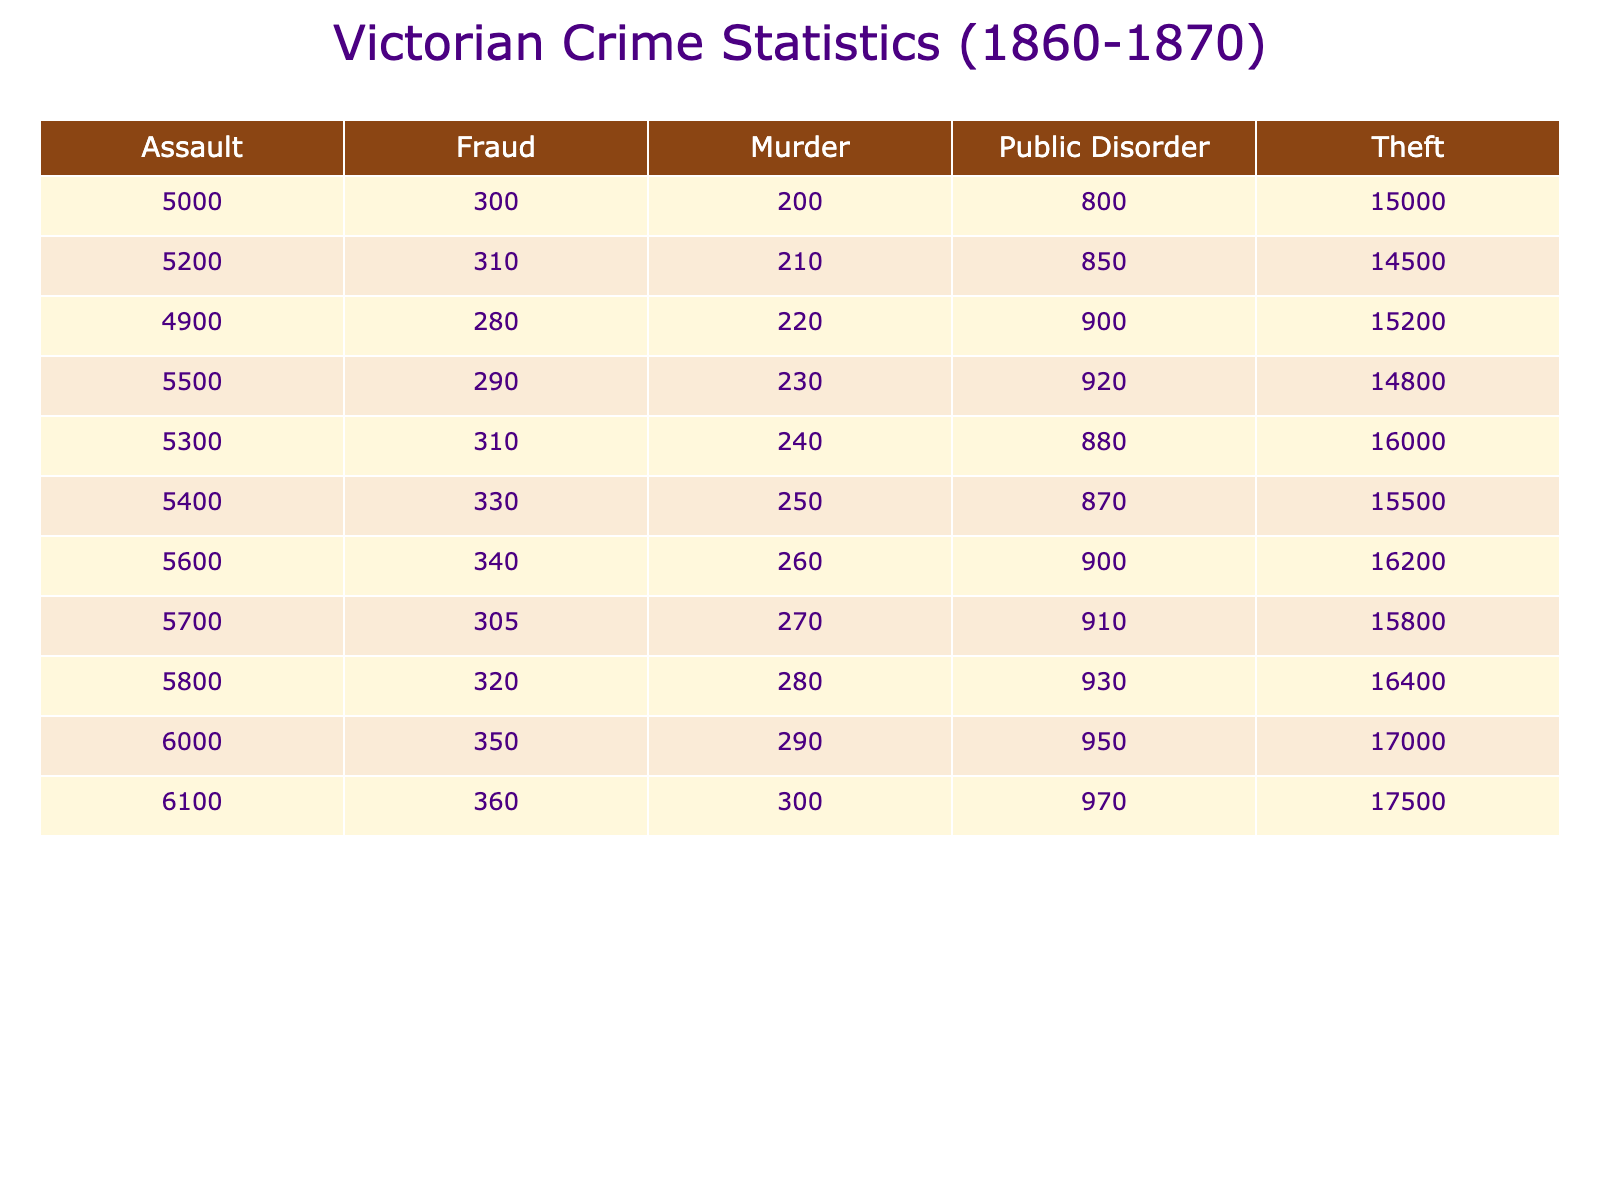What was the total number of thefts in 1865? To find the total number of thefts in 1865, we look at the "Theft" column for the year 1865, which has a value of 15500.
Answer: 15500 Which year had the highest number of assaults? The highest number of assaults can be found by scanning the "Assault" column. The maximum value is 6100, which corresponds to the year 1870.
Answer: 1870 What is the average number of murders per year from 1860 to 1870? To calculate the average number of murders, we sum the murder counts: 200 + 210 + 220 + 230 + 240 + 250 + 260 + 270 + 280 + 290 + 300 =  2100. Since there are 11 years, we divide 2100 by 11 to get approximately 190.91.
Answer: 190.91 Was there a decrease in public disorder incidents from 1860 to 1865? To determine if there was a decrease, we compare the value in 1860 (800) to 1865 (870). Since 870 is greater than 800, this indicates an increase in public disorder incidents.
Answer: No What is the difference in thefts between the years 1861 and 1870? To find the difference in thefts between 1861 and 1870, we subtract the number of thefts in 1861 (14500) from the number in 1870 (17500): 17500 - 14500 = 3000.
Answer: 3000 How many total incidents of fraud were reported from 1860 to 1869? To calculate the total incidents of fraud from 1860 to 1869, we sum the values in the "Fraud" column: 300 + 310 + 280 + 290 + 310 + 330 + 340 + 305 + 350 =  2815.
Answer: 2815 Is it true that the number of assaults increased every year from 1860 to 1870? To check this, we must examine the "Assault" column for each year. The values show that each year has a higher number than the previous year, confirming a consistent increase.
Answer: Yes Which crime type had the lowest count in 1863? Looking at the data for 1863, the values are Theft (14800), Assault (5500), Murder (230), Fraud (290), and Public Disorder (920). The lowest value is Murder with 230 incidents.
Answer: Murder What was the total number of crimes recorded in 1866? To find the total number of crimes in 1866, we sum the counts across all crime types: 16200 (Theft) + 5600 (Assault) + 260 (Murder) + 340 (Fraud) + 900 (Public Disorder) =  23500.
Answer: 23500 